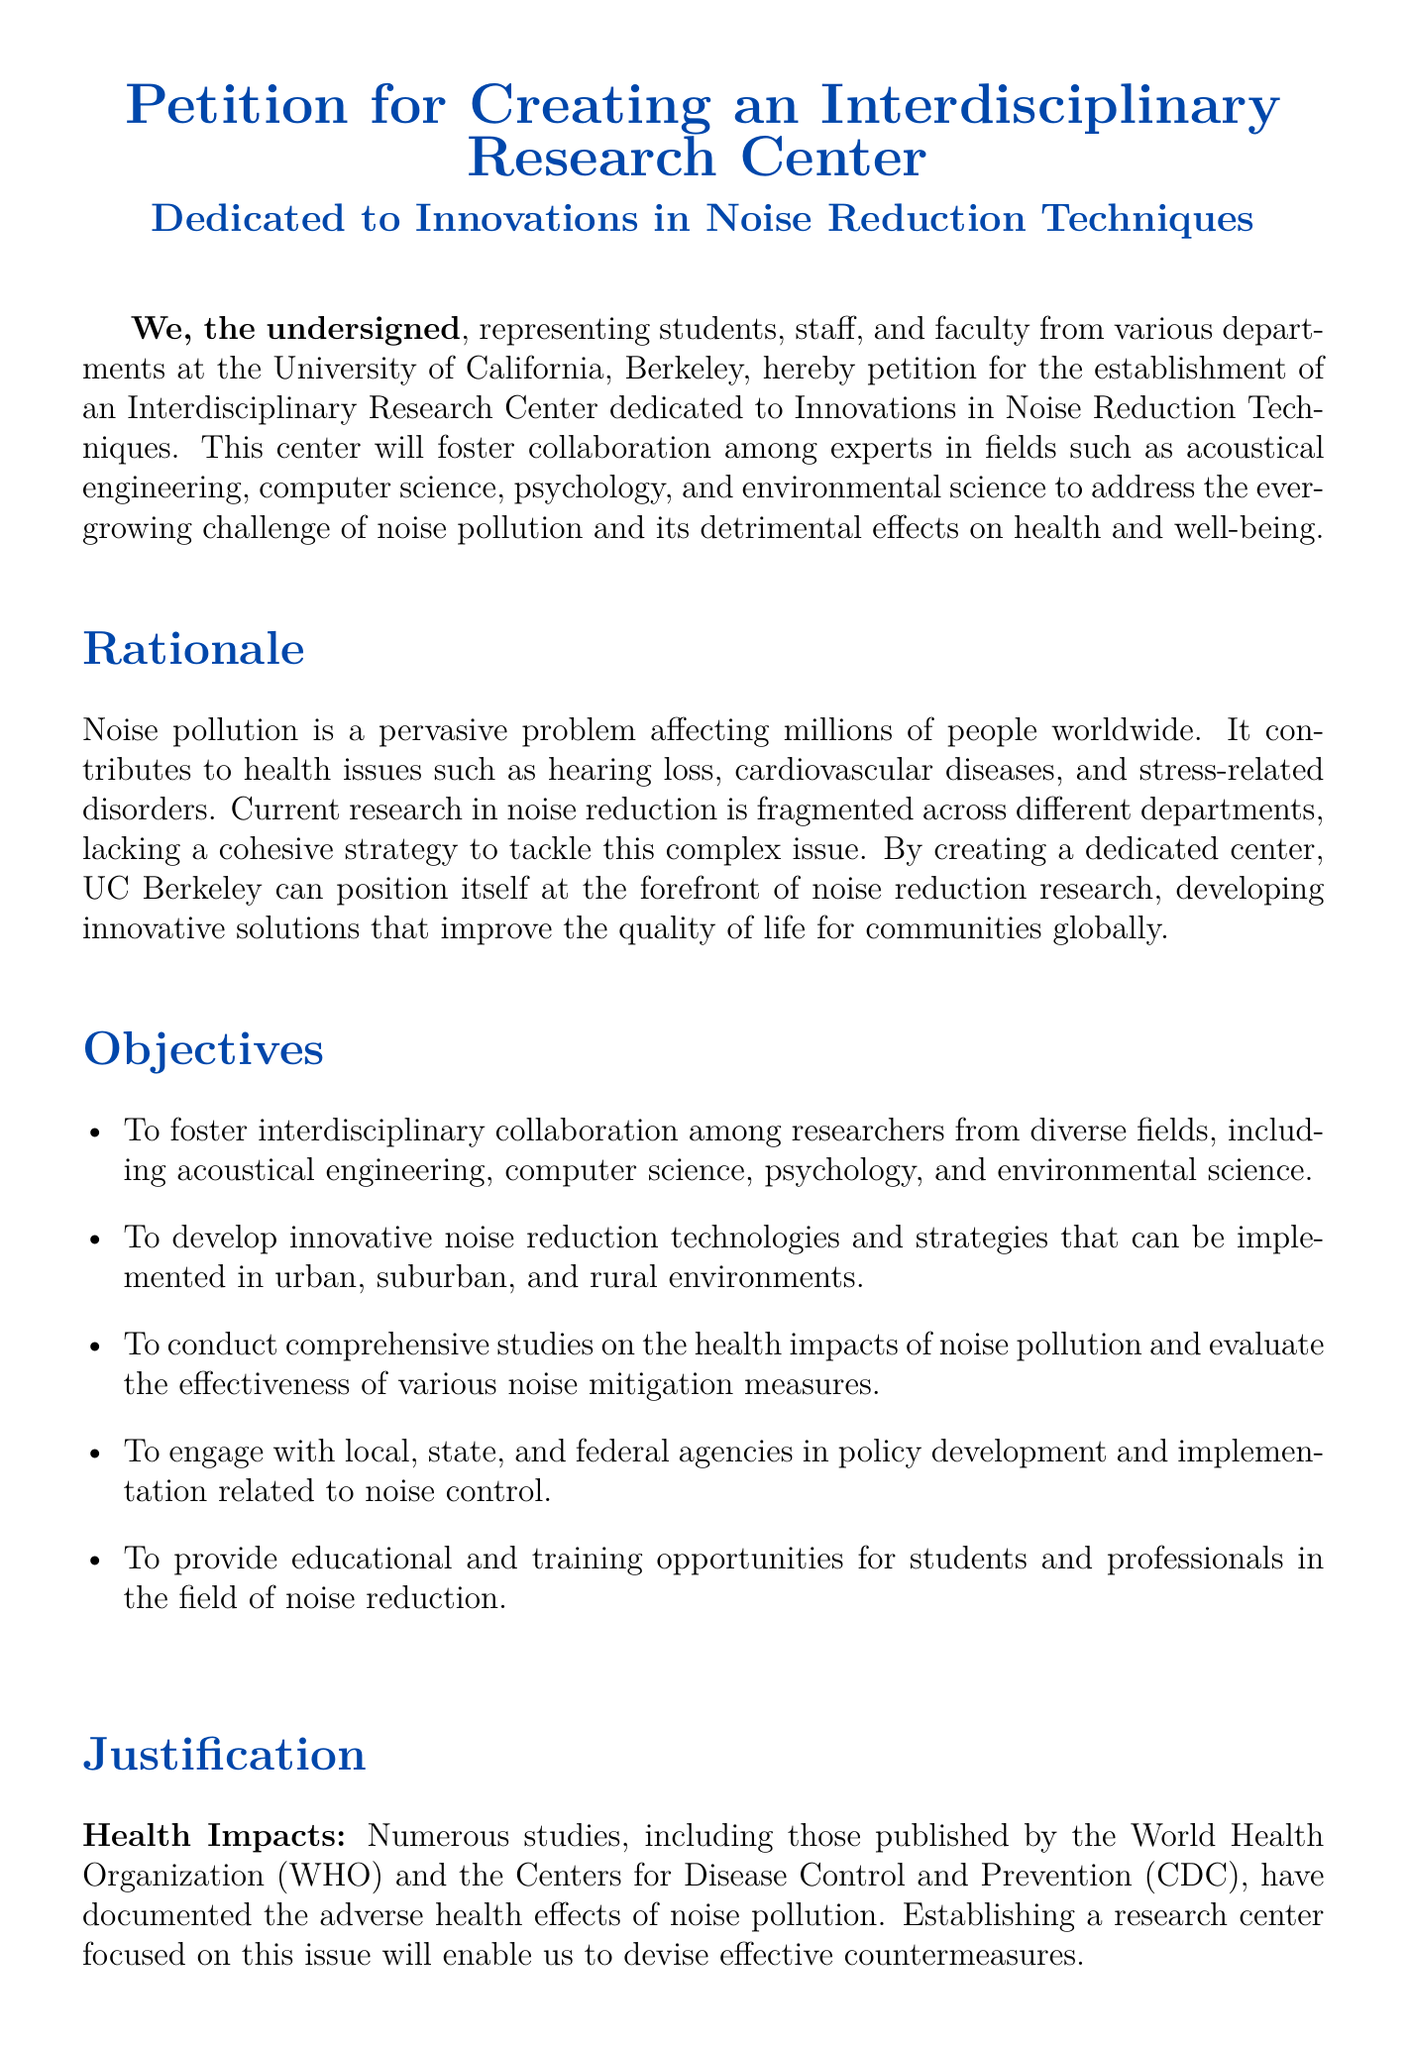What is the main purpose of the petition? The petition aims to establish an Interdisciplinary Research Center dedicated to Innovations in Noise Reduction Techniques.
Answer: Interdisciplinary Research Center dedicated to Innovations in Noise Reduction Techniques Who represents the signatories of the petition? The signatories represent students, staff, and faculty from various departments at the University of California, Berkeley.
Answer: Students, staff, and faculty from various departments What is one of the health issues caused by noise pollution mentioned? The document states that noise pollution contributes to health issues such as hearing loss.
Answer: Hearing loss What is one objective of the proposed research center? One objective is to develop innovative noise reduction technologies and strategies.
Answer: Develop innovative noise reduction technologies and strategies Which organization published studies on the health impacts of noise pollution? The document mentions studies published by the World Health Organization.
Answer: World Health Organization How many signatories are listed in the document? The document lists five signatories.
Answer: Five What is a key justification for creating the center? A key justification is to devise effective countermeasures against health impacts of noise pollution.
Answer: Devise effective countermeasures What fields are highlighted for interdisciplinary collaboration? The fields highlighted include acoustical engineering, computer science, psychology, and environmental science.
Answer: Acoustical engineering, computer science, psychology, environmental science What is the color theme used in the document? The color theme that is specified in the document is blue.
Answer: Blue 